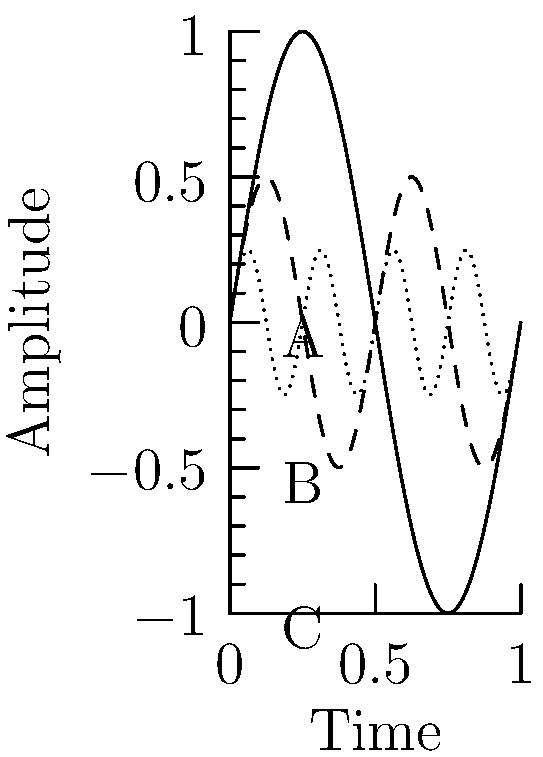As a composer creating vocal compositions, you're studying the waveform shapes of different vowel sounds on an oscilloscope. The graph shows three waveforms labeled A, B, and C. Which waveform is most likely to represent the vowel sound "ee" as in "sheep"? To answer this question, we need to consider the characteristics of different vowel sounds and their corresponding waveforms:

1. The vowel sound "ee" as in "sheep" is known as a high-frequency vowel.
2. High-frequency vowels typically have simpler waveforms with fewer harmonics.
3. Simpler waveforms appear more sinusoidal and have fewer oscillations within a given time period.

Analyzing the given waveforms:

A. This waveform has the lowest frequency (one complete cycle shown) and appears most sinusoidal.
B. This waveform has a medium frequency (two complete cycles shown) and is slightly more complex than A.
C. This waveform has the highest frequency (four complete cycles shown) and is the most complex of the three.

Given that the "ee" sound is a high-frequency vowel with a relatively simple waveform, we can conclude that waveform A is the most likely representation. It has the simplest, most sinusoidal shape, which is characteristic of high-frequency vowels like "ee".
Answer: A 